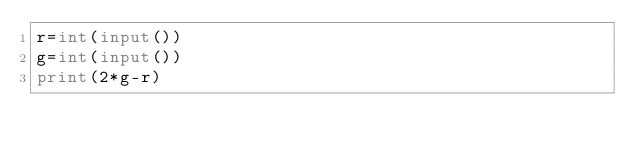Convert code to text. <code><loc_0><loc_0><loc_500><loc_500><_Python_>r=int(input())
g=int(input())
print(2*g-r)</code> 